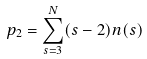Convert formula to latex. <formula><loc_0><loc_0><loc_500><loc_500>p _ { 2 } = \sum _ { s = 3 } ^ { N } ( s - 2 ) n ( s )</formula> 